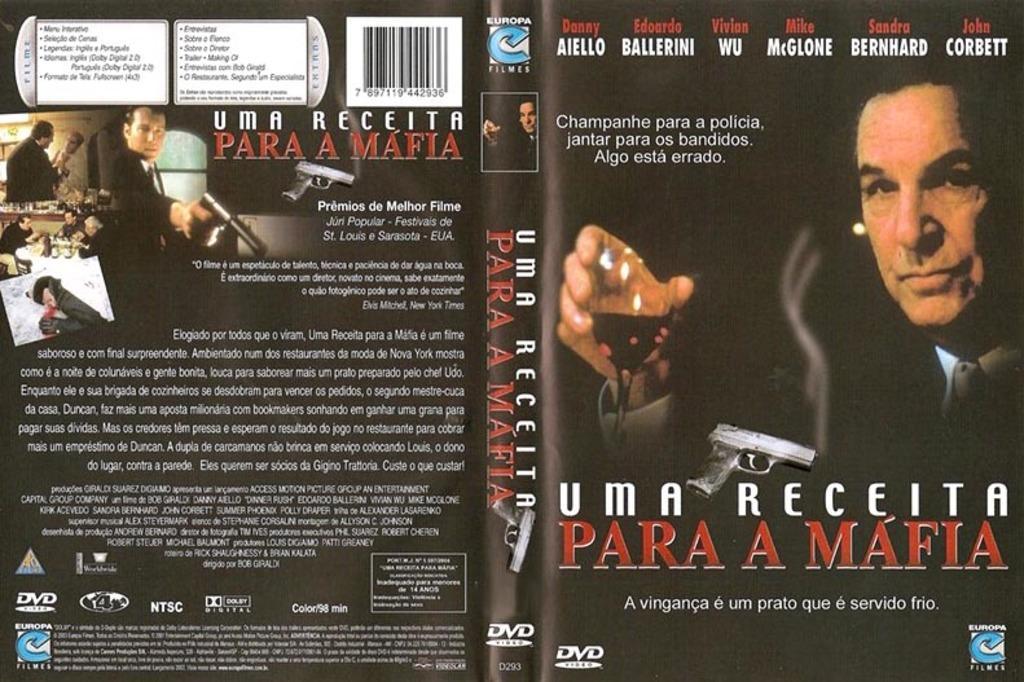Describe this image in one or two sentences. In this image I can see the poster in which I can see the group of people and I can see something written on the poster. 